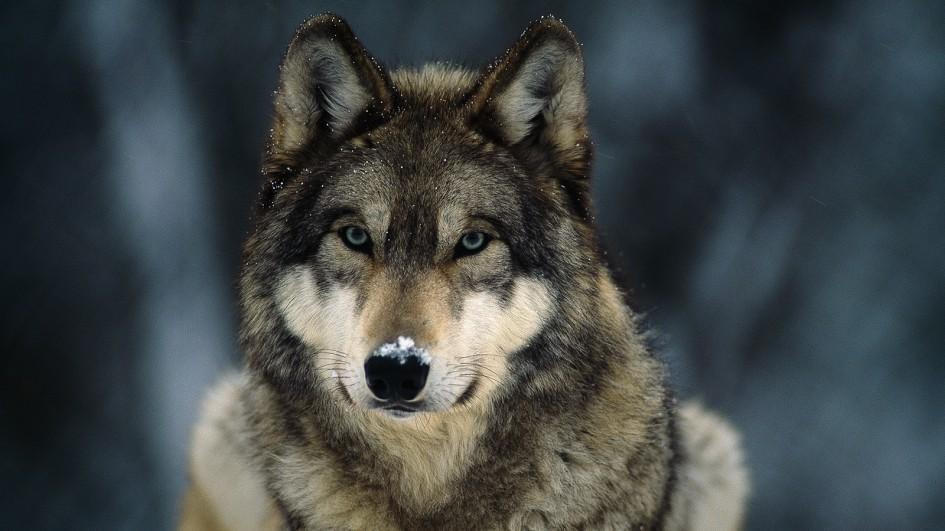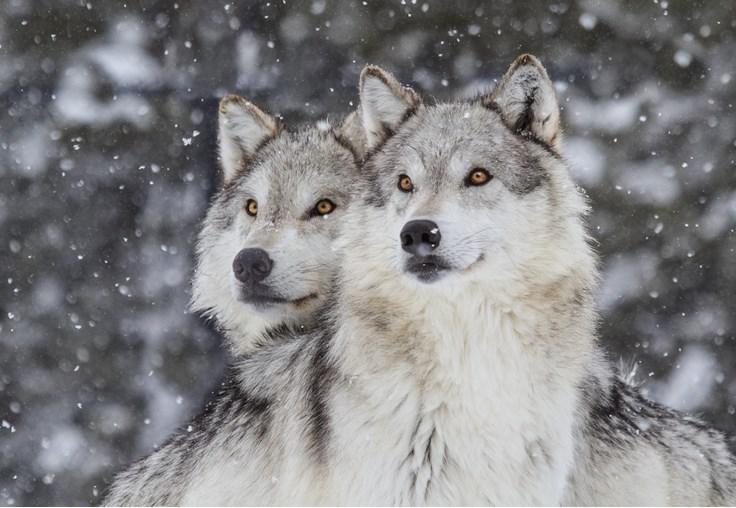The first image is the image on the left, the second image is the image on the right. Evaluate the accuracy of this statement regarding the images: "One image shows two wolves with their faces side-by-side, and the other image features one forward-looking wolf.". Is it true? Answer yes or no. Yes. The first image is the image on the left, the second image is the image on the right. Assess this claim about the two images: "there are two wolves standing close together". Correct or not? Answer yes or no. Yes. 